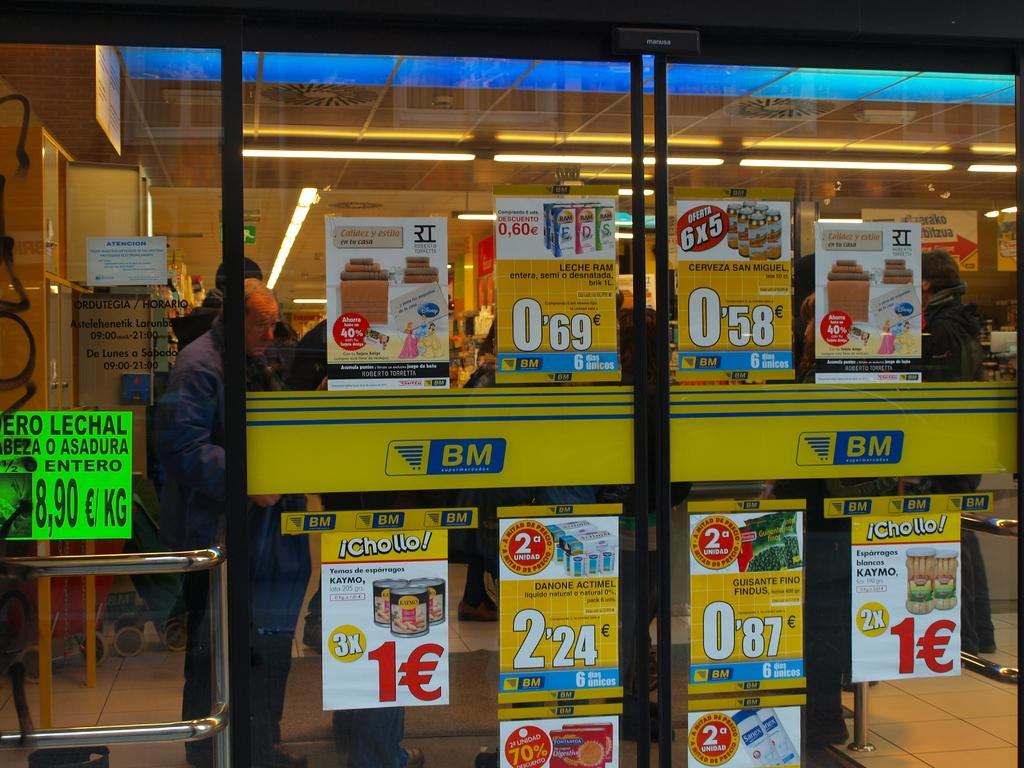<image>
Summarize the visual content of the image. BM is written on the automatic glass doors to a grocery store. 